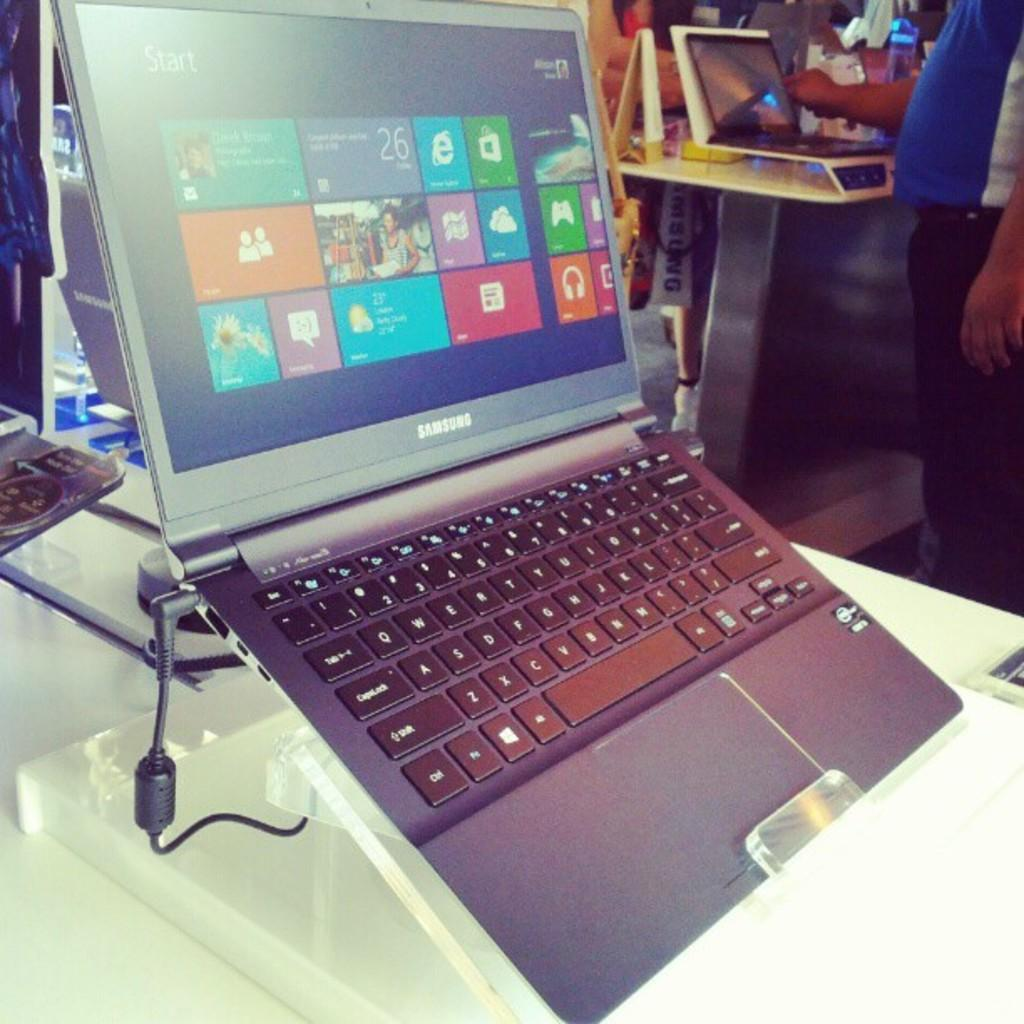What is the main object on the table in the image? There is a laptop on a table in the image. Can you describe the setting in the background of the image? There are tables with laptops on them in the background, and there are persons standing on either side of the tables. How many tables with laptops can be seen in the background? There are multiple tables with laptops visible in the background. Are there any giants present in the image? No, there are no giants present in the image. What type of representative can be seen in the image? There is no representative depicted in the image; it features tables with laptops and persons standing nearby. 